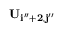<formula> <loc_0><loc_0><loc_500><loc_500>U _ { i ^ { \prime \prime } + 2 , j ^ { \prime \prime } }</formula> 